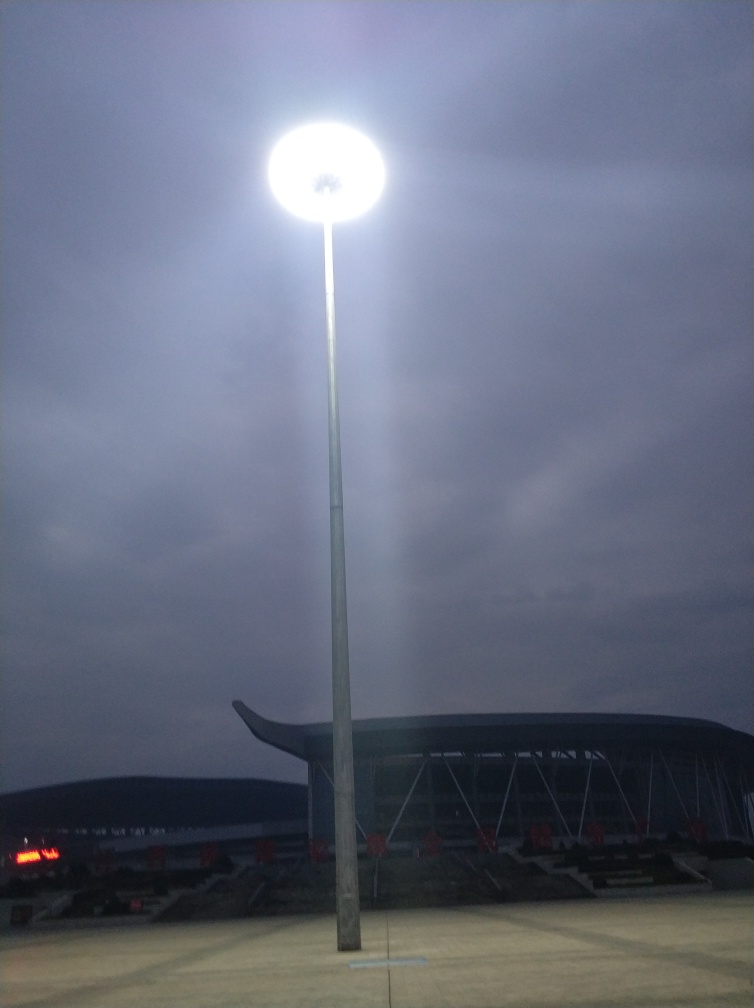What is the function of the large structure in the background? The large structure in the background looks like an outdoor sports stadium, identifiable by the rows of seating and the overall shape of the building. Is the stadium in use at the time this photo was taken? Based on the absence of a visible crowd and the dim light coming from within, it does not appear to be in active use at the moment the photo was captured. 